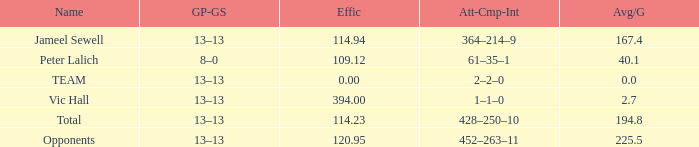What is the effectiveness for an avg/g of 394.0. 